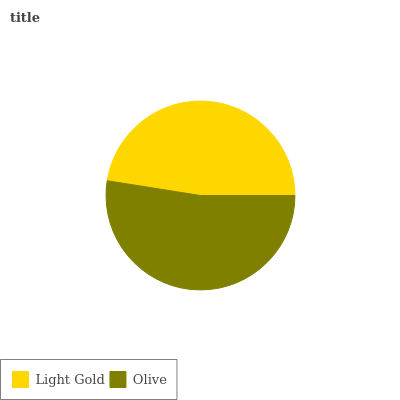Is Light Gold the minimum?
Answer yes or no. Yes. Is Olive the maximum?
Answer yes or no. Yes. Is Olive the minimum?
Answer yes or no. No. Is Olive greater than Light Gold?
Answer yes or no. Yes. Is Light Gold less than Olive?
Answer yes or no. Yes. Is Light Gold greater than Olive?
Answer yes or no. No. Is Olive less than Light Gold?
Answer yes or no. No. Is Olive the high median?
Answer yes or no. Yes. Is Light Gold the low median?
Answer yes or no. Yes. Is Light Gold the high median?
Answer yes or no. No. Is Olive the low median?
Answer yes or no. No. 